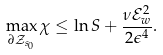Convert formula to latex. <formula><loc_0><loc_0><loc_500><loc_500>\max _ { \partial \mathcal { Z } _ { s _ { 0 } } } \chi \leq \ln S + \frac { \nu \mathcal { E } _ { w } ^ { 2 } } { 2 \epsilon ^ { 4 } } .</formula> 